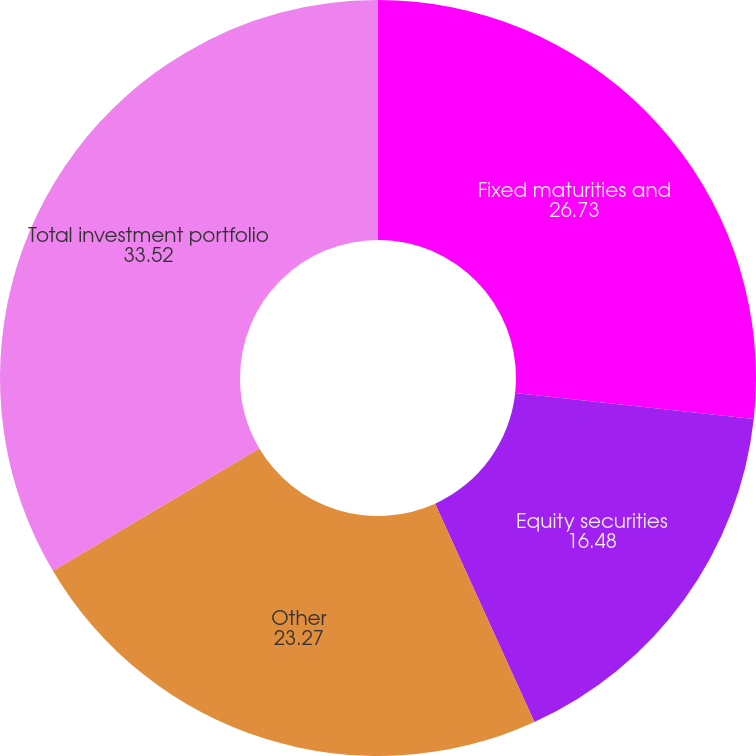Convert chart. <chart><loc_0><loc_0><loc_500><loc_500><pie_chart><fcel>Fixed maturities and<fcel>Equity securities<fcel>Other<fcel>Total investment portfolio<nl><fcel>26.73%<fcel>16.48%<fcel>23.27%<fcel>33.52%<nl></chart> 